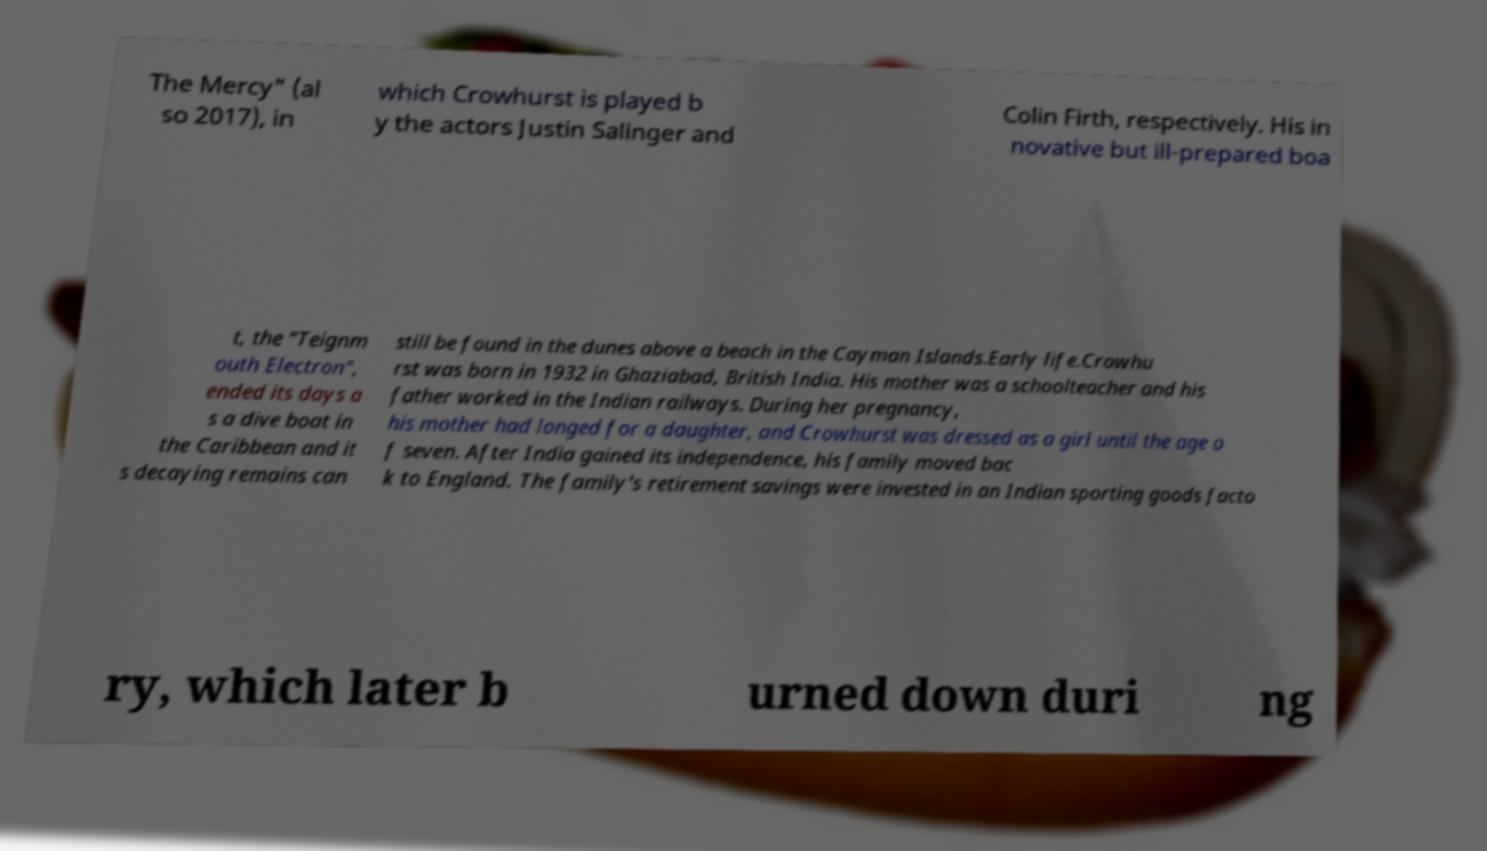I need the written content from this picture converted into text. Can you do that? The Mercy" (al so 2017), in which Crowhurst is played b y the actors Justin Salinger and Colin Firth, respectively. His in novative but ill-prepared boa t, the "Teignm outh Electron", ended its days a s a dive boat in the Caribbean and it s decaying remains can still be found in the dunes above a beach in the Cayman Islands.Early life.Crowhu rst was born in 1932 in Ghaziabad, British India. His mother was a schoolteacher and his father worked in the Indian railways. During her pregnancy, his mother had longed for a daughter, and Crowhurst was dressed as a girl until the age o f seven. After India gained its independence, his family moved bac k to England. The family's retirement savings were invested in an Indian sporting goods facto ry, which later b urned down duri ng 